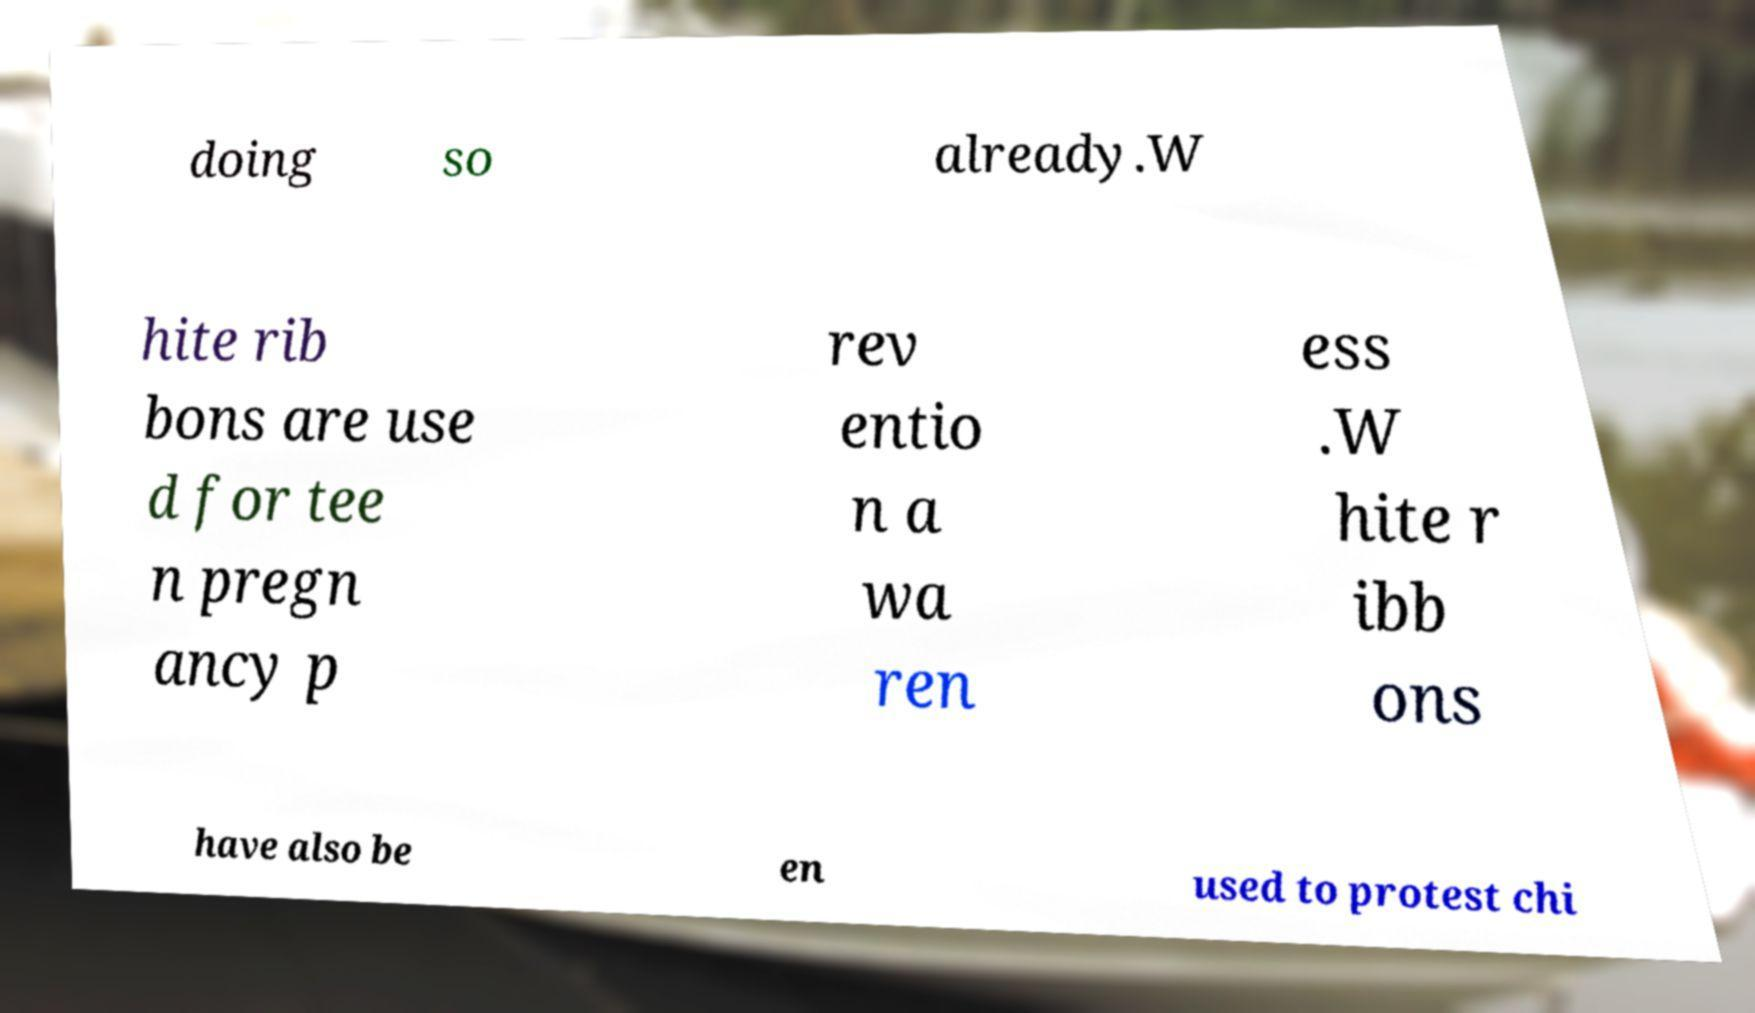I need the written content from this picture converted into text. Can you do that? doing so already.W hite rib bons are use d for tee n pregn ancy p rev entio n a wa ren ess .W hite r ibb ons have also be en used to protest chi 